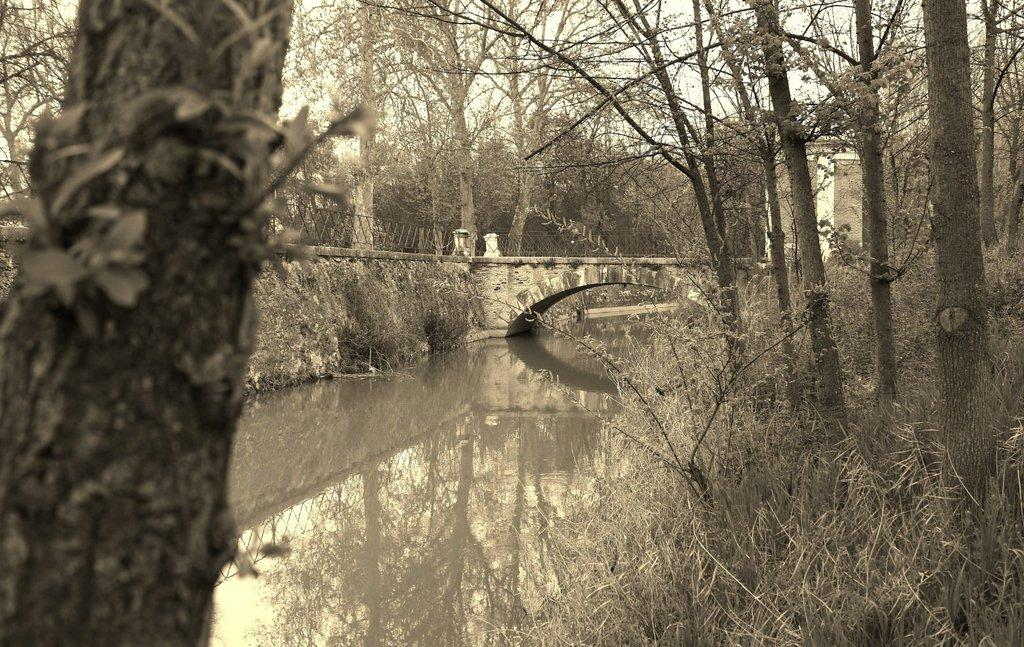What type of vegetation can be seen in the image? There are trees in the image. What natural element is visible in the image? There is water visible in the image. What type of barrier is present in the image? There is a fence in the image. What structure can be seen on the right side of the image? There is a building on the right side of the image. What is visible at the top of the image? The sky is visible at the top of the image. What type of yarn is being used to create the fence in the image? There is no yarn present in the image; the fence is made of a different material. Can you hear a whistle in the image? There is no whistle present in the image, so it cannot be heard. 